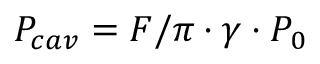<formula> <loc_0><loc_0><loc_500><loc_500>P _ { c a v } = { F / \pi } \cdot { \gamma } \cdot { P _ { 0 } }</formula> 